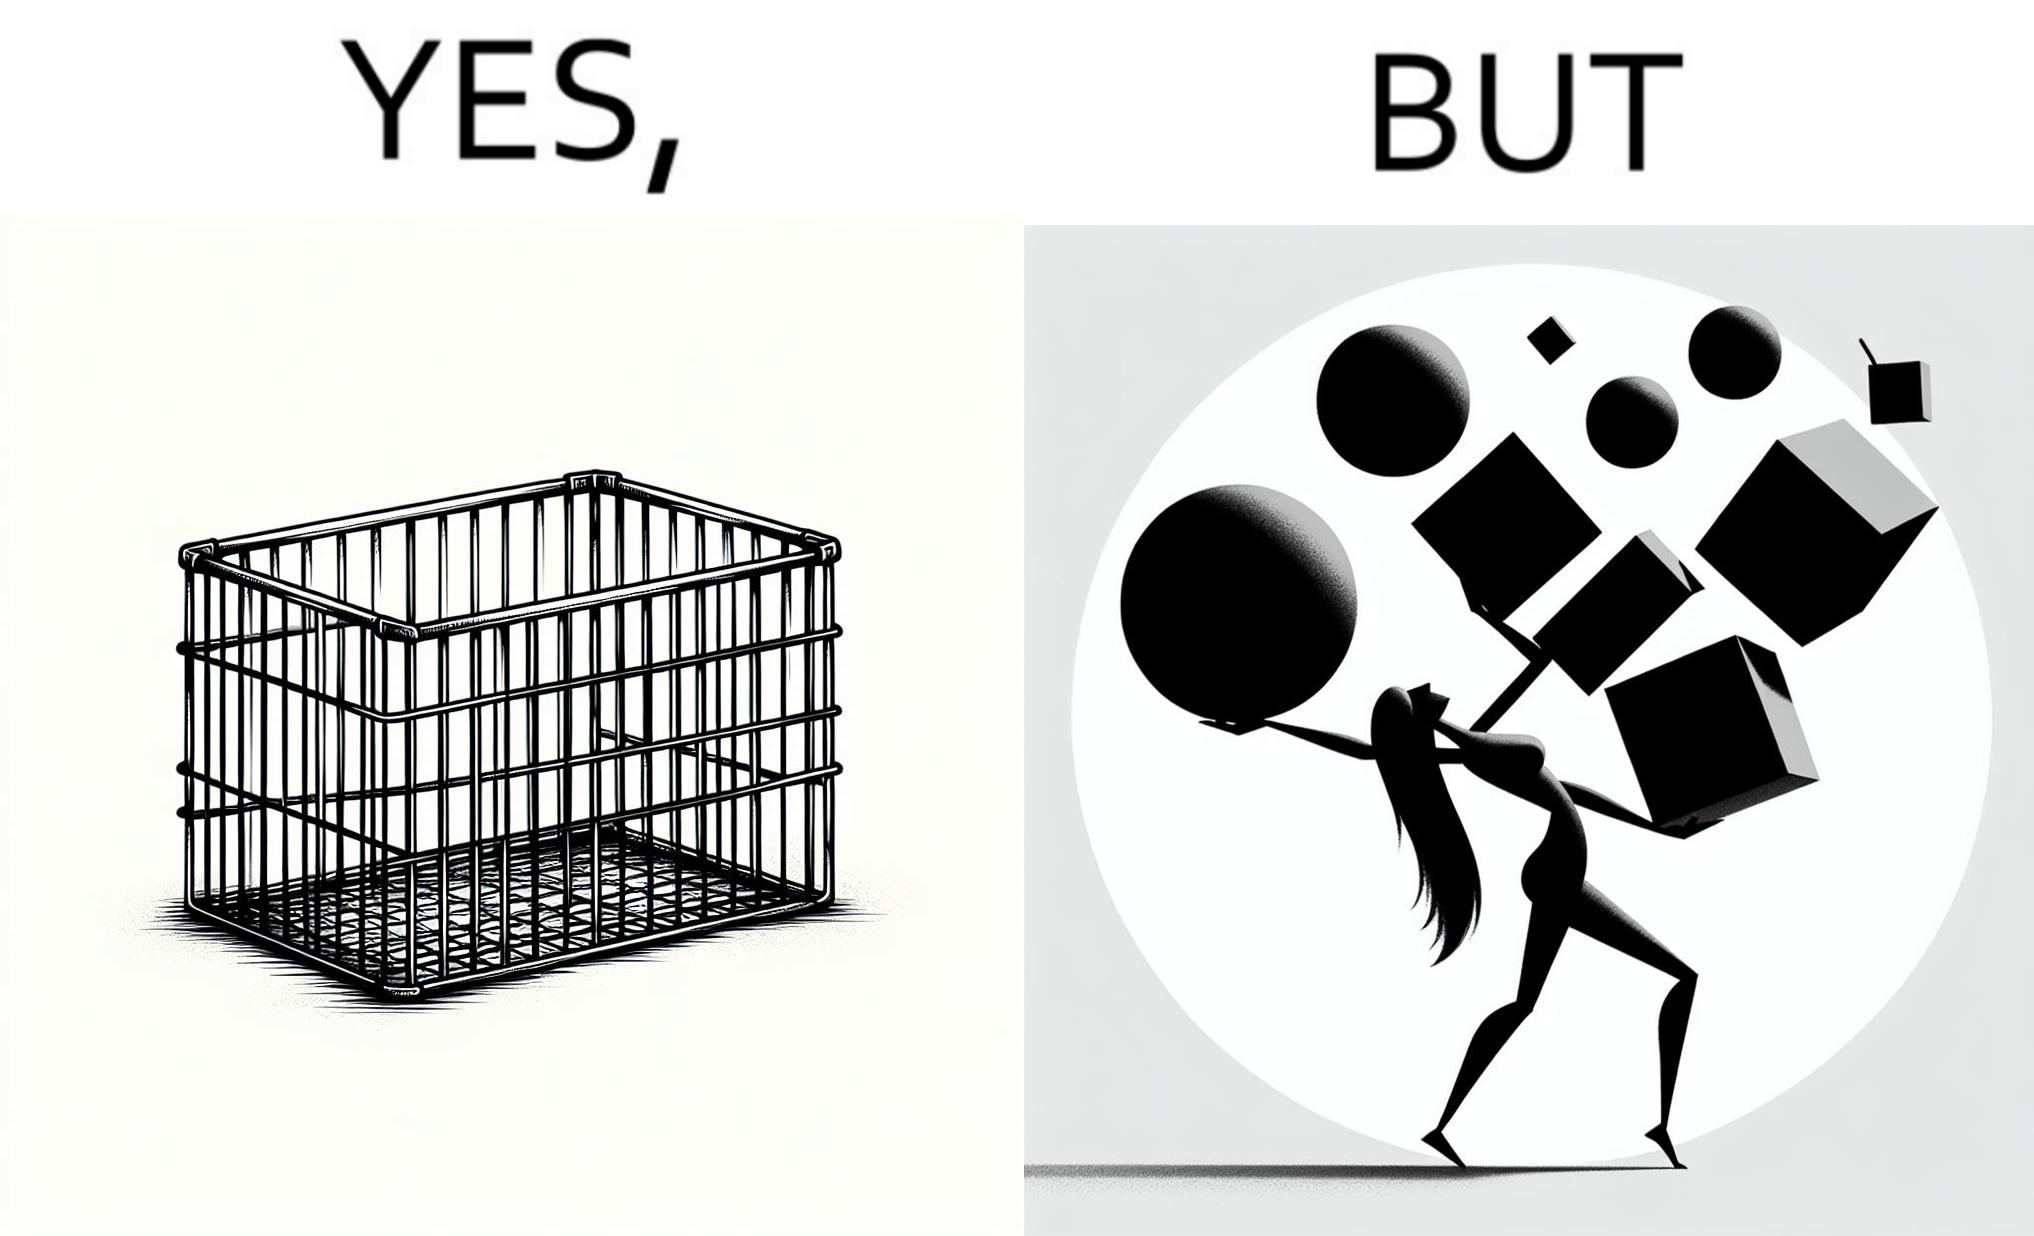Does this image contain satire or humor? Yes, this image is satirical. 